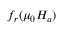<formula> <loc_0><loc_0><loc_500><loc_500>f _ { r } ( \mu _ { 0 } H _ { a } )</formula> 